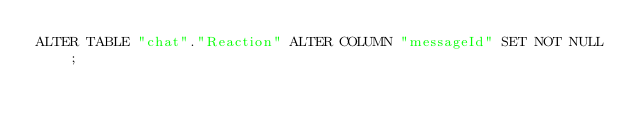<code> <loc_0><loc_0><loc_500><loc_500><_SQL_>ALTER TABLE "chat"."Reaction" ALTER COLUMN "messageId" SET NOT NULL;
</code> 